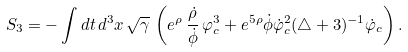Convert formula to latex. <formula><loc_0><loc_0><loc_500><loc_500>S _ { 3 } = - \int d t \, d ^ { 3 } x \, \sqrt { \gamma } \, \left ( e ^ { \rho } \, \frac { \dot { \rho } } { \dot { \phi } } \, \varphi _ { c } ^ { 3 } + e ^ { 5 \rho } \dot { \phi } \dot { \varphi } _ { c } ^ { 2 } ( \triangle + 3 ) ^ { - 1 } \dot { \varphi } _ { c } \right ) .</formula> 